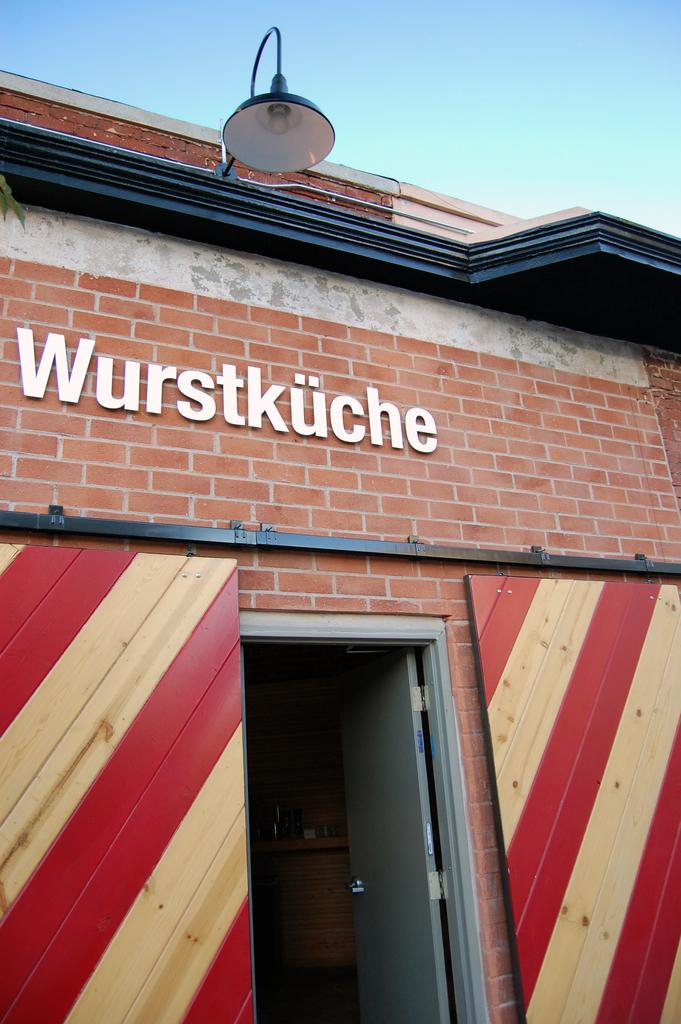What type of structure is present in the image? There is a building in the image. Can you describe any specific features of the building? There is a door in the image, and there is a light at the top of the building. What can be seen in the background of the image? The sky is visible in the image. How many glasses of water are on the windowsill of the building in the image? There is no mention of glasses of water or a windowsill in the image, so it cannot be determined from the image. 